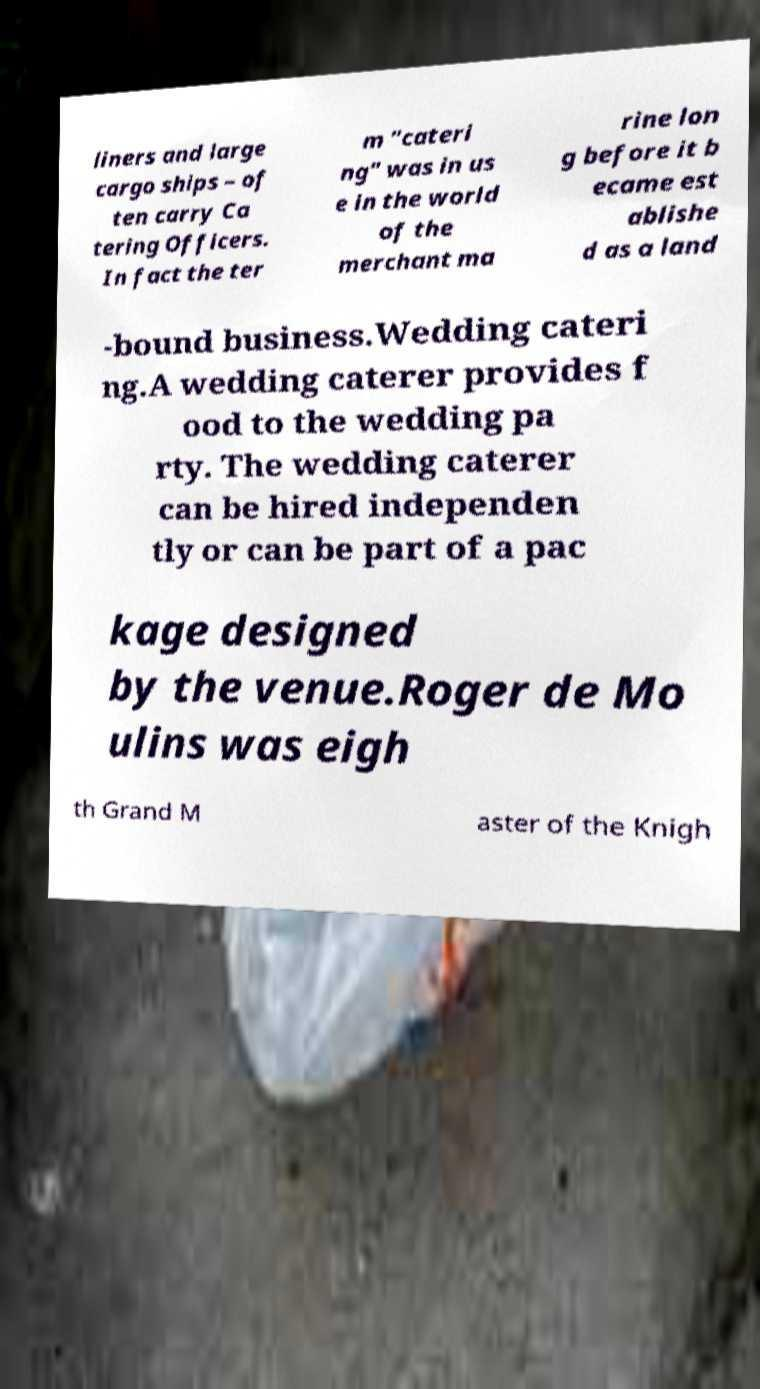Please read and relay the text visible in this image. What does it say? liners and large cargo ships – of ten carry Ca tering Officers. In fact the ter m "cateri ng" was in us e in the world of the merchant ma rine lon g before it b ecame est ablishe d as a land -bound business.Wedding cateri ng.A wedding caterer provides f ood to the wedding pa rty. The wedding caterer can be hired independen tly or can be part of a pac kage designed by the venue.Roger de Mo ulins was eigh th Grand M aster of the Knigh 